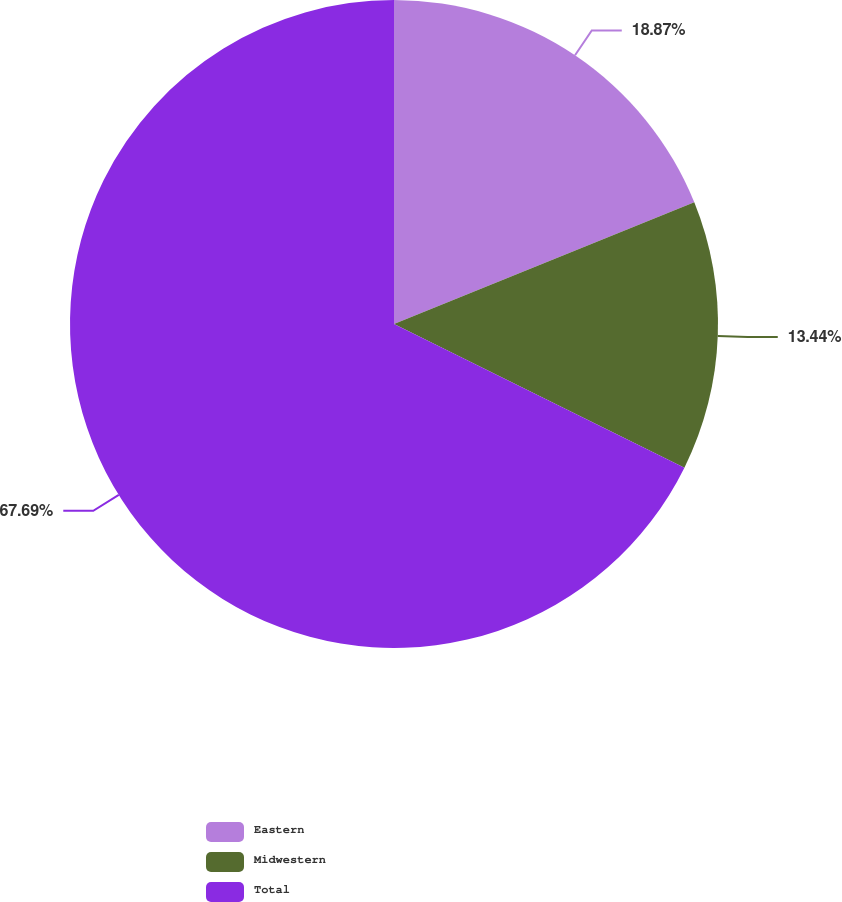Convert chart to OTSL. <chart><loc_0><loc_0><loc_500><loc_500><pie_chart><fcel>Eastern<fcel>Midwestern<fcel>Total<nl><fcel>18.87%<fcel>13.44%<fcel>67.69%<nl></chart> 